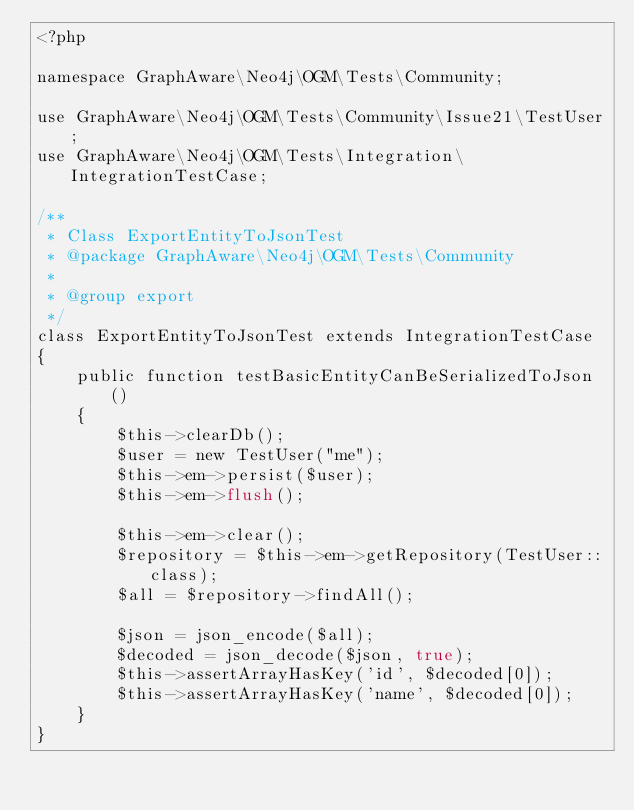<code> <loc_0><loc_0><loc_500><loc_500><_PHP_><?php

namespace GraphAware\Neo4j\OGM\Tests\Community;

use GraphAware\Neo4j\OGM\Tests\Community\Issue21\TestUser;
use GraphAware\Neo4j\OGM\Tests\Integration\IntegrationTestCase;

/**
 * Class ExportEntityToJsonTest
 * @package GraphAware\Neo4j\OGM\Tests\Community
 *
 * @group export
 */
class ExportEntityToJsonTest extends IntegrationTestCase
{
    public function testBasicEntityCanBeSerializedToJson()
    {
        $this->clearDb();
        $user = new TestUser("me");
        $this->em->persist($user);
        $this->em->flush();

        $this->em->clear();
        $repository = $this->em->getRepository(TestUser::class);
        $all = $repository->findAll();

        $json = json_encode($all);
        $decoded = json_decode($json, true);
        $this->assertArrayHasKey('id', $decoded[0]);
        $this->assertArrayHasKey('name', $decoded[0]);
    }
}</code> 